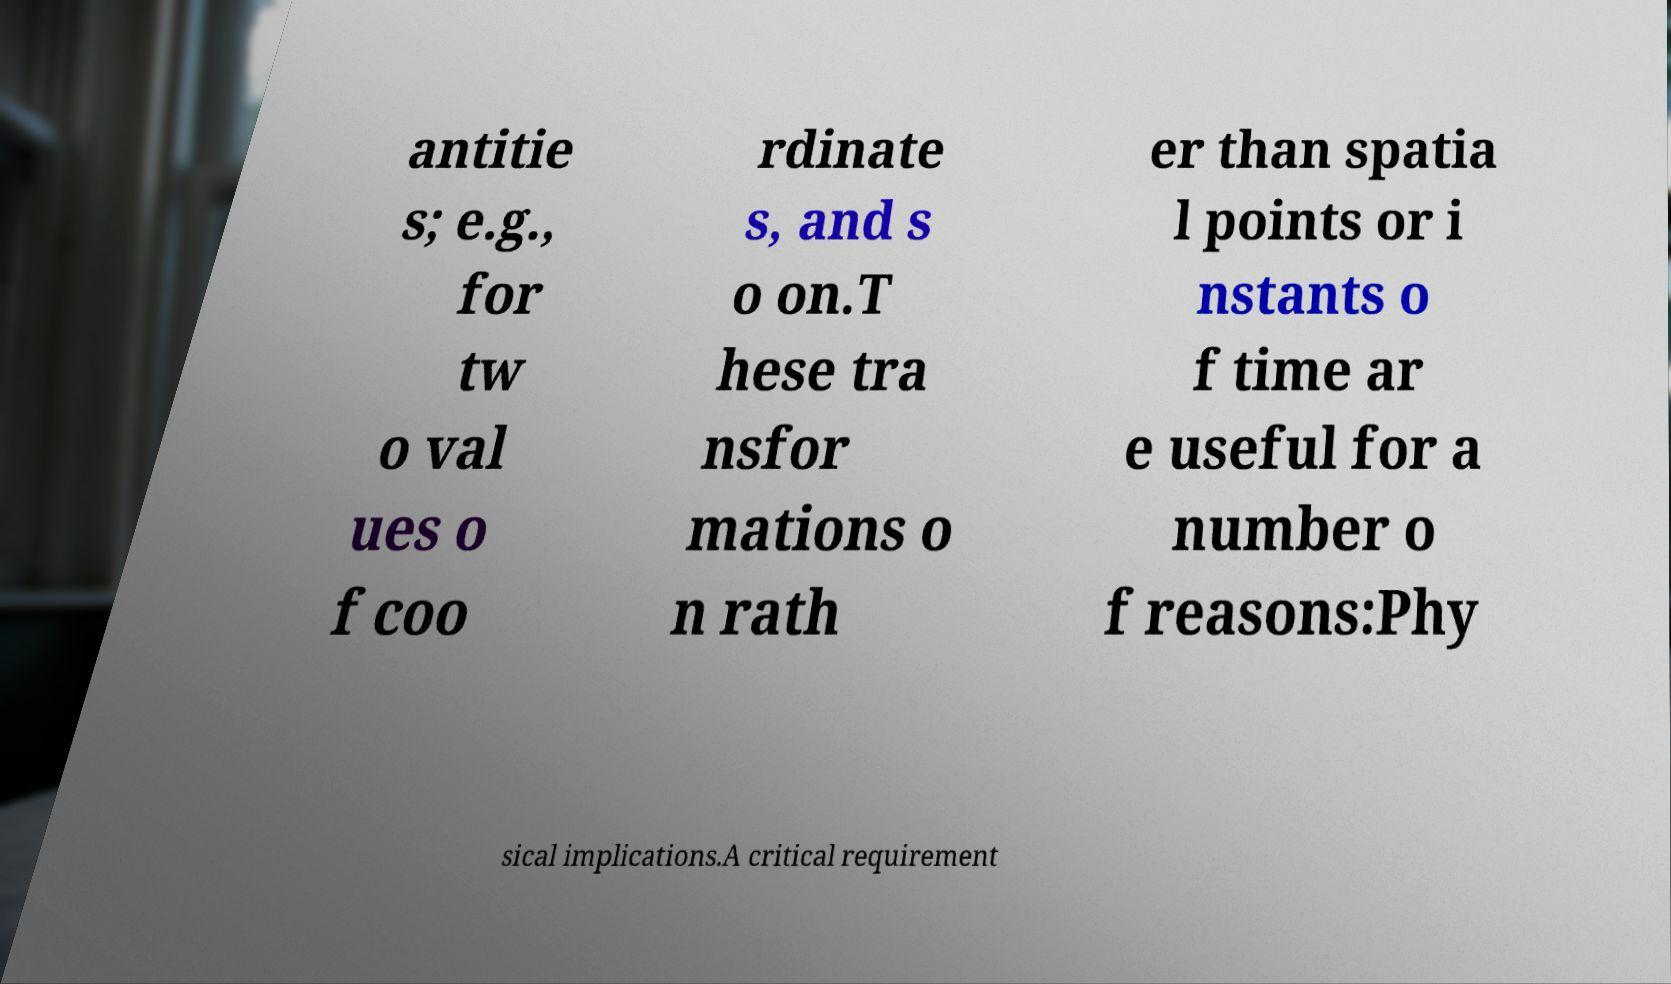Please identify and transcribe the text found in this image. antitie s; e.g., for tw o val ues o f coo rdinate s, and s o on.T hese tra nsfor mations o n rath er than spatia l points or i nstants o f time ar e useful for a number o f reasons:Phy sical implications.A critical requirement 